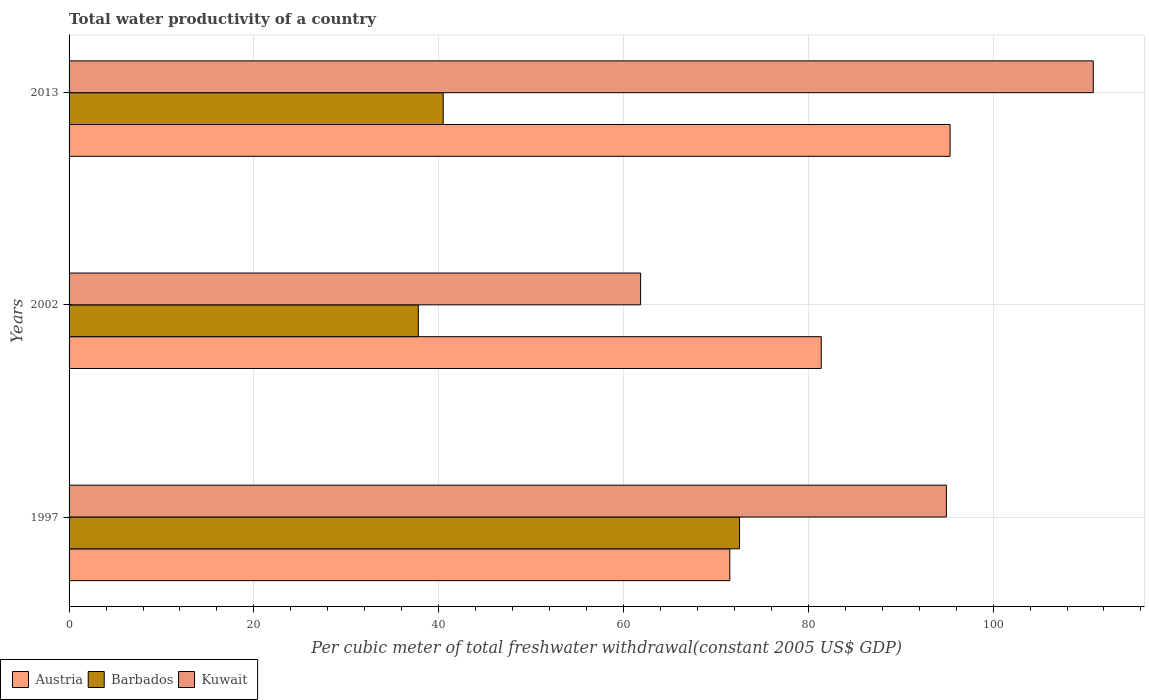Are the number of bars per tick equal to the number of legend labels?
Your response must be concise. Yes. Are the number of bars on each tick of the Y-axis equal?
Your response must be concise. Yes. How many bars are there on the 1st tick from the bottom?
Offer a terse response. 3. What is the total water productivity in Barbados in 1997?
Your response must be concise. 72.56. Across all years, what is the maximum total water productivity in Barbados?
Keep it short and to the point. 72.56. Across all years, what is the minimum total water productivity in Kuwait?
Make the answer very short. 61.86. In which year was the total water productivity in Barbados maximum?
Offer a terse response. 1997. In which year was the total water productivity in Austria minimum?
Keep it short and to the point. 1997. What is the total total water productivity in Kuwait in the graph?
Your answer should be very brief. 267.64. What is the difference between the total water productivity in Austria in 1997 and that in 2002?
Provide a succinct answer. -9.9. What is the difference between the total water productivity in Kuwait in 1997 and the total water productivity in Austria in 2013?
Offer a very short reply. -0.4. What is the average total water productivity in Austria per year?
Offer a terse response. 82.75. In the year 2013, what is the difference between the total water productivity in Austria and total water productivity in Barbados?
Provide a short and direct response. 54.86. In how many years, is the total water productivity in Barbados greater than 68 US$?
Your response must be concise. 1. What is the ratio of the total water productivity in Barbados in 1997 to that in 2013?
Your answer should be very brief. 1.79. Is the total water productivity in Barbados in 2002 less than that in 2013?
Give a very brief answer. Yes. What is the difference between the highest and the second highest total water productivity in Barbados?
Offer a terse response. 32.07. What is the difference between the highest and the lowest total water productivity in Barbados?
Give a very brief answer. 34.76. In how many years, is the total water productivity in Kuwait greater than the average total water productivity in Kuwait taken over all years?
Your response must be concise. 2. Is the sum of the total water productivity in Kuwait in 1997 and 2002 greater than the maximum total water productivity in Austria across all years?
Offer a very short reply. Yes. What does the 2nd bar from the top in 1997 represents?
Give a very brief answer. Barbados. What does the 1st bar from the bottom in 2013 represents?
Provide a succinct answer. Austria. Is it the case that in every year, the sum of the total water productivity in Kuwait and total water productivity in Austria is greater than the total water productivity in Barbados?
Provide a short and direct response. Yes. Are all the bars in the graph horizontal?
Provide a succinct answer. Yes. What is the difference between two consecutive major ticks on the X-axis?
Offer a very short reply. 20. Does the graph contain any zero values?
Offer a very short reply. No. What is the title of the graph?
Give a very brief answer. Total water productivity of a country. Does "Other small states" appear as one of the legend labels in the graph?
Your answer should be very brief. No. What is the label or title of the X-axis?
Your answer should be very brief. Per cubic meter of total freshwater withdrawal(constant 2005 US$ GDP). What is the Per cubic meter of total freshwater withdrawal(constant 2005 US$ GDP) of Austria in 1997?
Your response must be concise. 71.5. What is the Per cubic meter of total freshwater withdrawal(constant 2005 US$ GDP) in Barbados in 1997?
Your answer should be very brief. 72.56. What is the Per cubic meter of total freshwater withdrawal(constant 2005 US$ GDP) of Kuwait in 1997?
Make the answer very short. 94.94. What is the Per cubic meter of total freshwater withdrawal(constant 2005 US$ GDP) in Austria in 2002?
Your answer should be very brief. 81.4. What is the Per cubic meter of total freshwater withdrawal(constant 2005 US$ GDP) of Barbados in 2002?
Your response must be concise. 37.8. What is the Per cubic meter of total freshwater withdrawal(constant 2005 US$ GDP) of Kuwait in 2002?
Your answer should be compact. 61.86. What is the Per cubic meter of total freshwater withdrawal(constant 2005 US$ GDP) in Austria in 2013?
Provide a succinct answer. 95.35. What is the Per cubic meter of total freshwater withdrawal(constant 2005 US$ GDP) in Barbados in 2013?
Ensure brevity in your answer.  40.49. What is the Per cubic meter of total freshwater withdrawal(constant 2005 US$ GDP) in Kuwait in 2013?
Offer a very short reply. 110.84. Across all years, what is the maximum Per cubic meter of total freshwater withdrawal(constant 2005 US$ GDP) of Austria?
Give a very brief answer. 95.35. Across all years, what is the maximum Per cubic meter of total freshwater withdrawal(constant 2005 US$ GDP) in Barbados?
Ensure brevity in your answer.  72.56. Across all years, what is the maximum Per cubic meter of total freshwater withdrawal(constant 2005 US$ GDP) in Kuwait?
Provide a succinct answer. 110.84. Across all years, what is the minimum Per cubic meter of total freshwater withdrawal(constant 2005 US$ GDP) in Austria?
Offer a very short reply. 71.5. Across all years, what is the minimum Per cubic meter of total freshwater withdrawal(constant 2005 US$ GDP) of Barbados?
Give a very brief answer. 37.8. Across all years, what is the minimum Per cubic meter of total freshwater withdrawal(constant 2005 US$ GDP) of Kuwait?
Keep it short and to the point. 61.86. What is the total Per cubic meter of total freshwater withdrawal(constant 2005 US$ GDP) in Austria in the graph?
Make the answer very short. 248.25. What is the total Per cubic meter of total freshwater withdrawal(constant 2005 US$ GDP) in Barbados in the graph?
Give a very brief answer. 150.84. What is the total Per cubic meter of total freshwater withdrawal(constant 2005 US$ GDP) of Kuwait in the graph?
Ensure brevity in your answer.  267.64. What is the difference between the Per cubic meter of total freshwater withdrawal(constant 2005 US$ GDP) of Austria in 1997 and that in 2002?
Your answer should be compact. -9.9. What is the difference between the Per cubic meter of total freshwater withdrawal(constant 2005 US$ GDP) in Barbados in 1997 and that in 2002?
Your answer should be compact. 34.76. What is the difference between the Per cubic meter of total freshwater withdrawal(constant 2005 US$ GDP) of Kuwait in 1997 and that in 2002?
Provide a succinct answer. 33.09. What is the difference between the Per cubic meter of total freshwater withdrawal(constant 2005 US$ GDP) of Austria in 1997 and that in 2013?
Provide a short and direct response. -23.84. What is the difference between the Per cubic meter of total freshwater withdrawal(constant 2005 US$ GDP) in Barbados in 1997 and that in 2013?
Your response must be concise. 32.07. What is the difference between the Per cubic meter of total freshwater withdrawal(constant 2005 US$ GDP) of Kuwait in 1997 and that in 2013?
Offer a terse response. -15.9. What is the difference between the Per cubic meter of total freshwater withdrawal(constant 2005 US$ GDP) in Austria in 2002 and that in 2013?
Provide a succinct answer. -13.94. What is the difference between the Per cubic meter of total freshwater withdrawal(constant 2005 US$ GDP) of Barbados in 2002 and that in 2013?
Your answer should be very brief. -2.69. What is the difference between the Per cubic meter of total freshwater withdrawal(constant 2005 US$ GDP) in Kuwait in 2002 and that in 2013?
Your response must be concise. -48.99. What is the difference between the Per cubic meter of total freshwater withdrawal(constant 2005 US$ GDP) in Austria in 1997 and the Per cubic meter of total freshwater withdrawal(constant 2005 US$ GDP) in Barbados in 2002?
Provide a short and direct response. 33.71. What is the difference between the Per cubic meter of total freshwater withdrawal(constant 2005 US$ GDP) in Austria in 1997 and the Per cubic meter of total freshwater withdrawal(constant 2005 US$ GDP) in Kuwait in 2002?
Provide a short and direct response. 9.65. What is the difference between the Per cubic meter of total freshwater withdrawal(constant 2005 US$ GDP) of Barbados in 1997 and the Per cubic meter of total freshwater withdrawal(constant 2005 US$ GDP) of Kuwait in 2002?
Give a very brief answer. 10.7. What is the difference between the Per cubic meter of total freshwater withdrawal(constant 2005 US$ GDP) of Austria in 1997 and the Per cubic meter of total freshwater withdrawal(constant 2005 US$ GDP) of Barbados in 2013?
Your response must be concise. 31.02. What is the difference between the Per cubic meter of total freshwater withdrawal(constant 2005 US$ GDP) in Austria in 1997 and the Per cubic meter of total freshwater withdrawal(constant 2005 US$ GDP) in Kuwait in 2013?
Your answer should be very brief. -39.34. What is the difference between the Per cubic meter of total freshwater withdrawal(constant 2005 US$ GDP) of Barbados in 1997 and the Per cubic meter of total freshwater withdrawal(constant 2005 US$ GDP) of Kuwait in 2013?
Offer a terse response. -38.28. What is the difference between the Per cubic meter of total freshwater withdrawal(constant 2005 US$ GDP) in Austria in 2002 and the Per cubic meter of total freshwater withdrawal(constant 2005 US$ GDP) in Barbados in 2013?
Offer a very short reply. 40.91. What is the difference between the Per cubic meter of total freshwater withdrawal(constant 2005 US$ GDP) of Austria in 2002 and the Per cubic meter of total freshwater withdrawal(constant 2005 US$ GDP) of Kuwait in 2013?
Offer a very short reply. -29.44. What is the difference between the Per cubic meter of total freshwater withdrawal(constant 2005 US$ GDP) in Barbados in 2002 and the Per cubic meter of total freshwater withdrawal(constant 2005 US$ GDP) in Kuwait in 2013?
Provide a succinct answer. -73.05. What is the average Per cubic meter of total freshwater withdrawal(constant 2005 US$ GDP) of Austria per year?
Your answer should be compact. 82.75. What is the average Per cubic meter of total freshwater withdrawal(constant 2005 US$ GDP) in Barbados per year?
Keep it short and to the point. 50.28. What is the average Per cubic meter of total freshwater withdrawal(constant 2005 US$ GDP) of Kuwait per year?
Offer a terse response. 89.21. In the year 1997, what is the difference between the Per cubic meter of total freshwater withdrawal(constant 2005 US$ GDP) of Austria and Per cubic meter of total freshwater withdrawal(constant 2005 US$ GDP) of Barbados?
Make the answer very short. -1.06. In the year 1997, what is the difference between the Per cubic meter of total freshwater withdrawal(constant 2005 US$ GDP) in Austria and Per cubic meter of total freshwater withdrawal(constant 2005 US$ GDP) in Kuwait?
Your answer should be very brief. -23.44. In the year 1997, what is the difference between the Per cubic meter of total freshwater withdrawal(constant 2005 US$ GDP) in Barbados and Per cubic meter of total freshwater withdrawal(constant 2005 US$ GDP) in Kuwait?
Provide a succinct answer. -22.38. In the year 2002, what is the difference between the Per cubic meter of total freshwater withdrawal(constant 2005 US$ GDP) in Austria and Per cubic meter of total freshwater withdrawal(constant 2005 US$ GDP) in Barbados?
Offer a very short reply. 43.6. In the year 2002, what is the difference between the Per cubic meter of total freshwater withdrawal(constant 2005 US$ GDP) of Austria and Per cubic meter of total freshwater withdrawal(constant 2005 US$ GDP) of Kuwait?
Offer a terse response. 19.55. In the year 2002, what is the difference between the Per cubic meter of total freshwater withdrawal(constant 2005 US$ GDP) in Barbados and Per cubic meter of total freshwater withdrawal(constant 2005 US$ GDP) in Kuwait?
Your answer should be compact. -24.06. In the year 2013, what is the difference between the Per cubic meter of total freshwater withdrawal(constant 2005 US$ GDP) in Austria and Per cubic meter of total freshwater withdrawal(constant 2005 US$ GDP) in Barbados?
Make the answer very short. 54.86. In the year 2013, what is the difference between the Per cubic meter of total freshwater withdrawal(constant 2005 US$ GDP) of Austria and Per cubic meter of total freshwater withdrawal(constant 2005 US$ GDP) of Kuwait?
Your answer should be very brief. -15.5. In the year 2013, what is the difference between the Per cubic meter of total freshwater withdrawal(constant 2005 US$ GDP) of Barbados and Per cubic meter of total freshwater withdrawal(constant 2005 US$ GDP) of Kuwait?
Make the answer very short. -70.36. What is the ratio of the Per cubic meter of total freshwater withdrawal(constant 2005 US$ GDP) of Austria in 1997 to that in 2002?
Your response must be concise. 0.88. What is the ratio of the Per cubic meter of total freshwater withdrawal(constant 2005 US$ GDP) in Barbados in 1997 to that in 2002?
Ensure brevity in your answer.  1.92. What is the ratio of the Per cubic meter of total freshwater withdrawal(constant 2005 US$ GDP) of Kuwait in 1997 to that in 2002?
Your answer should be very brief. 1.53. What is the ratio of the Per cubic meter of total freshwater withdrawal(constant 2005 US$ GDP) in Austria in 1997 to that in 2013?
Ensure brevity in your answer.  0.75. What is the ratio of the Per cubic meter of total freshwater withdrawal(constant 2005 US$ GDP) of Barbados in 1997 to that in 2013?
Provide a succinct answer. 1.79. What is the ratio of the Per cubic meter of total freshwater withdrawal(constant 2005 US$ GDP) in Kuwait in 1997 to that in 2013?
Provide a short and direct response. 0.86. What is the ratio of the Per cubic meter of total freshwater withdrawal(constant 2005 US$ GDP) of Austria in 2002 to that in 2013?
Give a very brief answer. 0.85. What is the ratio of the Per cubic meter of total freshwater withdrawal(constant 2005 US$ GDP) in Barbados in 2002 to that in 2013?
Offer a very short reply. 0.93. What is the ratio of the Per cubic meter of total freshwater withdrawal(constant 2005 US$ GDP) of Kuwait in 2002 to that in 2013?
Your answer should be compact. 0.56. What is the difference between the highest and the second highest Per cubic meter of total freshwater withdrawal(constant 2005 US$ GDP) in Austria?
Make the answer very short. 13.94. What is the difference between the highest and the second highest Per cubic meter of total freshwater withdrawal(constant 2005 US$ GDP) of Barbados?
Provide a short and direct response. 32.07. What is the difference between the highest and the second highest Per cubic meter of total freshwater withdrawal(constant 2005 US$ GDP) in Kuwait?
Make the answer very short. 15.9. What is the difference between the highest and the lowest Per cubic meter of total freshwater withdrawal(constant 2005 US$ GDP) in Austria?
Provide a short and direct response. 23.84. What is the difference between the highest and the lowest Per cubic meter of total freshwater withdrawal(constant 2005 US$ GDP) in Barbados?
Your answer should be very brief. 34.76. What is the difference between the highest and the lowest Per cubic meter of total freshwater withdrawal(constant 2005 US$ GDP) in Kuwait?
Your answer should be very brief. 48.99. 